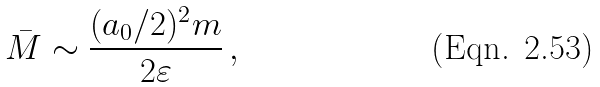<formula> <loc_0><loc_0><loc_500><loc_500>\bar { M } \sim \frac { ( a _ { 0 } / 2 ) ^ { 2 } m } { 2 \varepsilon } \, ,</formula> 